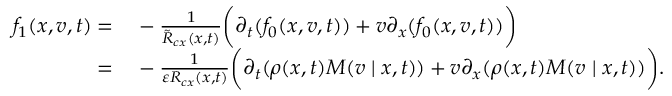<formula> <loc_0><loc_0><loc_500><loc_500>\begin{array} { r l } { f _ { 1 } ( x , v , t ) = } & - \frac { 1 } { \tilde { R } _ { c x } ( x , t ) } \left ( \partial _ { t } ( f _ { 0 } ( x , v , t ) ) + v \partial _ { x } ( f _ { 0 } ( x , v , t ) ) \right ) } \\ { = } & - \frac { 1 } { \varepsilon R _ { c x } ( x , t ) } \left ( \partial _ { t } ( \rho ( x , t ) M ( v | x , t ) ) + v \partial _ { x } ( \rho ( x , t ) M ( v | x , t ) ) \right ) . } \end{array}</formula> 